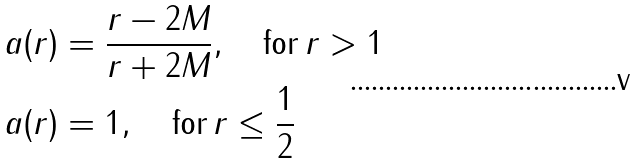<formula> <loc_0><loc_0><loc_500><loc_500>& a ( r ) = \frac { r - 2 M } { r + 2 M } , \quad { \text {for} } \, r > 1 \\ & a ( r ) = 1 , \quad { \text {for} } \, r \leq \frac { 1 } { 2 }</formula> 